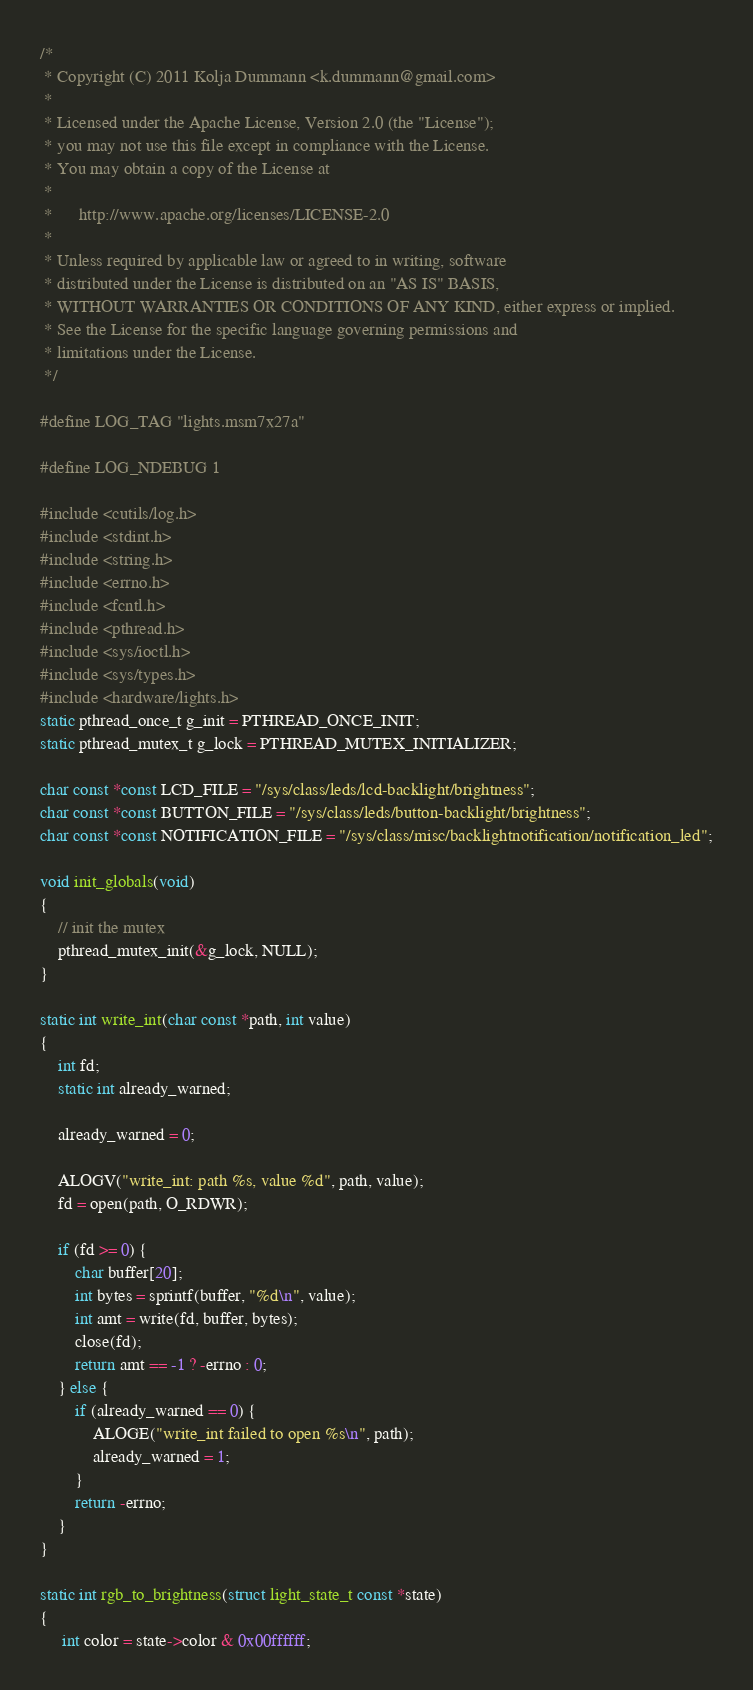Convert code to text. <code><loc_0><loc_0><loc_500><loc_500><_C_>/*
 * Copyright (C) 2011 Kolja Dummann <k.dummann@gmail.com>
 *
 * Licensed under the Apache License, Version 2.0 (the "License");
 * you may not use this file except in compliance with the License.
 * You may obtain a copy of the License at
 *
 *      http://www.apache.org/licenses/LICENSE-2.0
 *
 * Unless required by applicable law or agreed to in writing, software
 * distributed under the License is distributed on an "AS IS" BASIS,
 * WITHOUT WARRANTIES OR CONDITIONS OF ANY KIND, either express or implied.
 * See the License for the specific language governing permissions and
 * limitations under the License.
 */

#define LOG_TAG "lights.msm7x27a"

#define LOG_NDEBUG 1

#include <cutils/log.h>
#include <stdint.h>
#include <string.h>
#include <errno.h>
#include <fcntl.h>
#include <pthread.h>
#include <sys/ioctl.h>
#include <sys/types.h>
#include <hardware/lights.h>
static pthread_once_t g_init = PTHREAD_ONCE_INIT;
static pthread_mutex_t g_lock = PTHREAD_MUTEX_INITIALIZER;

char const *const LCD_FILE = "/sys/class/leds/lcd-backlight/brightness";
char const *const BUTTON_FILE = "/sys/class/leds/button-backlight/brightness";
char const *const NOTIFICATION_FILE = "/sys/class/misc/backlightnotification/notification_led";

void init_globals(void)
{
    // init the mutex
    pthread_mutex_init(&g_lock, NULL);
}

static int write_int(char const *path, int value)
{
    int fd;
    static int already_warned;

    already_warned = 0;

    ALOGV("write_int: path %s, value %d", path, value);
    fd = open(path, O_RDWR);

    if (fd >= 0) {
        char buffer[20];
        int bytes = sprintf(buffer, "%d\n", value);
        int amt = write(fd, buffer, bytes);
        close(fd);
        return amt == -1 ? -errno : 0;
    } else {
        if (already_warned == 0) {
            ALOGE("write_int failed to open %s\n", path);
            already_warned = 1;
        }
        return -errno;
    }
}

static int rgb_to_brightness(struct light_state_t const *state)
{
     int color = state->color & 0x00ffffff;
</code> 